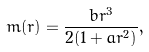<formula> <loc_0><loc_0><loc_500><loc_500>m ( r ) = \frac { b r ^ { 3 } } { 2 ( 1 + a r ^ { 2 } ) } ,</formula> 